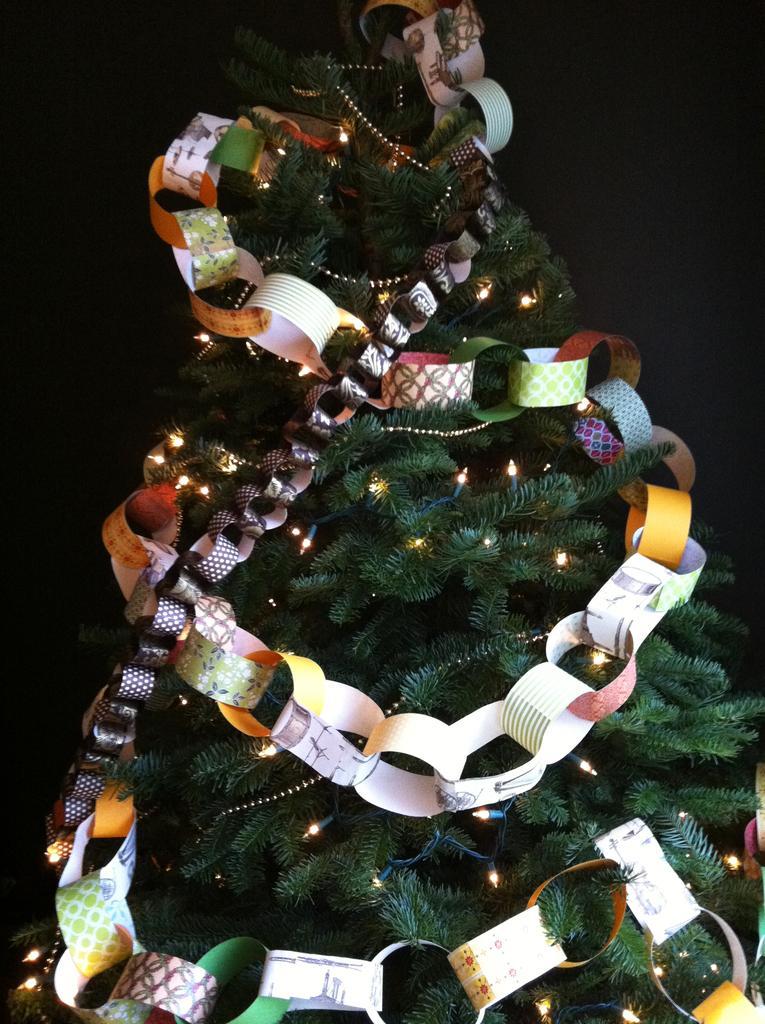Can you describe this image briefly? In this image in the center there is a tree and some lights and decorations, and there is black background. 